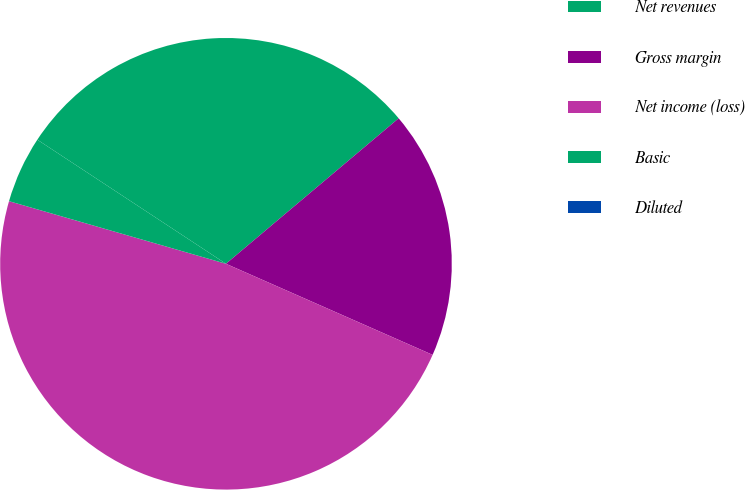Convert chart to OTSL. <chart><loc_0><loc_0><loc_500><loc_500><pie_chart><fcel>Net revenues<fcel>Gross margin<fcel>Net income (loss)<fcel>Basic<fcel>Diluted<nl><fcel>29.6%<fcel>17.75%<fcel>47.87%<fcel>4.79%<fcel>0.0%<nl></chart> 